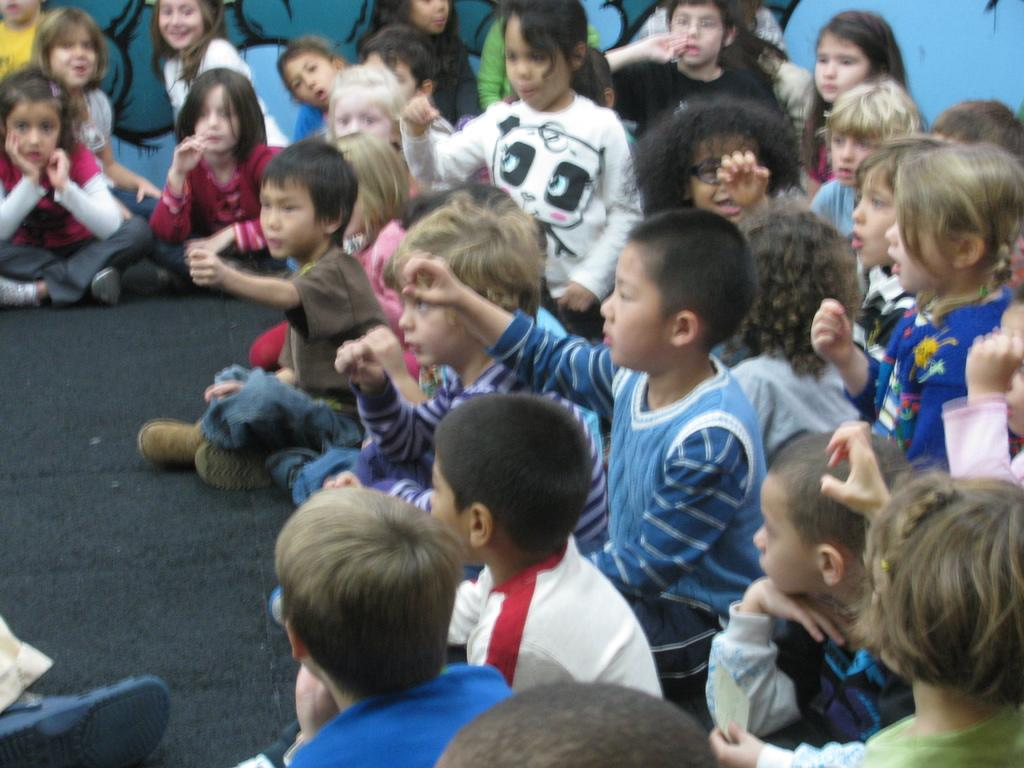What are the persons in the image doing? The persons in the image are sitting on the ground. Can you describe the background of the image? There is a painting on the wall in the background of the image. What type of band is playing in the image? There is no band present in the image; it only shows persons sitting on the ground and a painting on the wall in the background. 